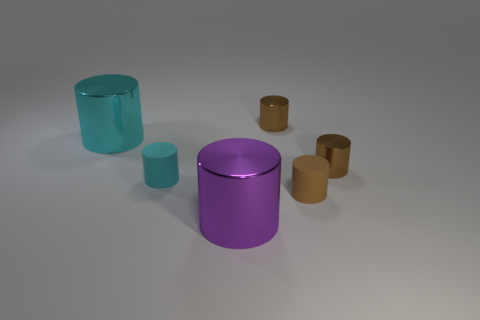There is a big cyan thing; are there any big metal things behind it?
Your response must be concise. No. What number of objects are either cyan things that are behind the small cyan thing or big metal cylinders?
Keep it short and to the point. 2. There is a tiny brown matte cylinder that is on the right side of the big purple shiny object; how many small brown metal things are right of it?
Keep it short and to the point. 1. Is the number of big cyan things that are in front of the brown matte thing less than the number of cyan things behind the small cyan matte object?
Give a very brief answer. Yes. What shape is the small brown metallic object behind the large metallic object that is behind the purple cylinder?
Offer a terse response. Cylinder. How many other things are there of the same material as the large cyan cylinder?
Ensure brevity in your answer.  3. Is the number of small brown shiny things greater than the number of cyan shiny objects?
Your answer should be very brief. Yes. How big is the object that is in front of the small cylinder that is in front of the matte thing on the left side of the large purple metal cylinder?
Provide a short and direct response. Large. Does the cyan metallic object have the same size as the cylinder that is in front of the brown matte cylinder?
Offer a terse response. Yes. Are there fewer purple cylinders that are behind the large purple metal cylinder than small brown shiny blocks?
Make the answer very short. No. 